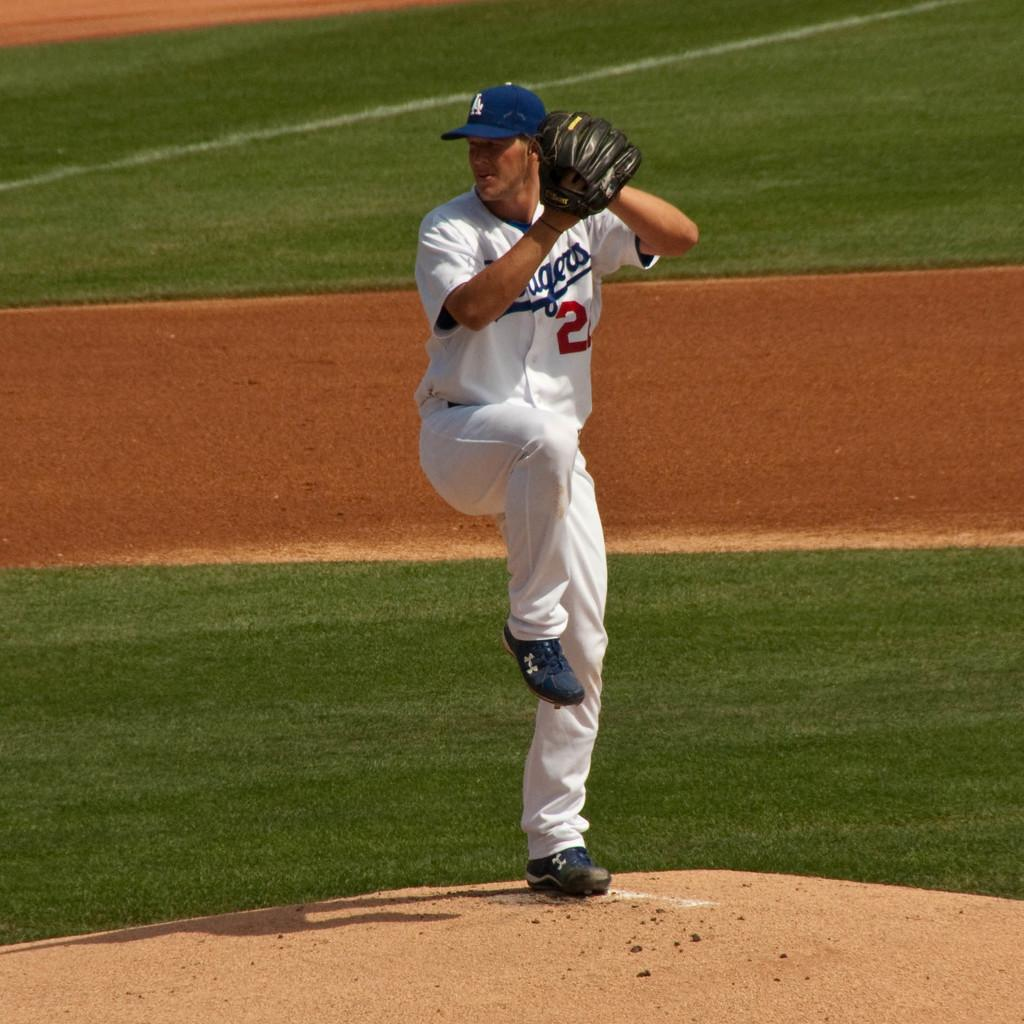<image>
Render a clear and concise summary of the photo. A pitcher for the Dodgers winds up to throw a pitch. 